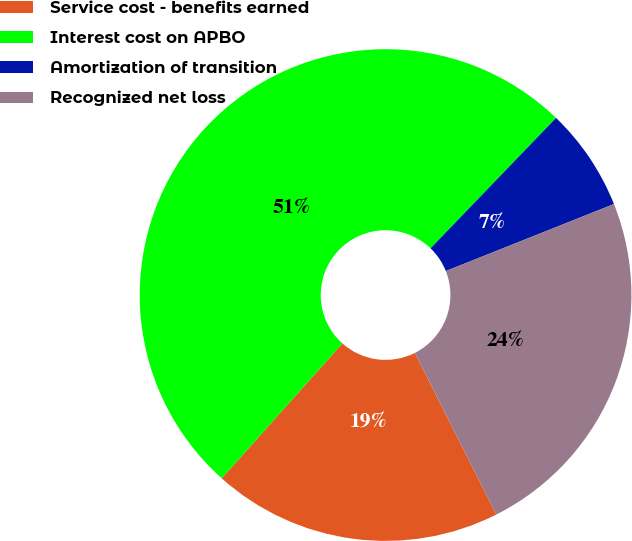<chart> <loc_0><loc_0><loc_500><loc_500><pie_chart><fcel>Service cost - benefits earned<fcel>Interest cost on APBO<fcel>Amortization of transition<fcel>Recognized net loss<nl><fcel>19.05%<fcel>50.59%<fcel>6.77%<fcel>23.6%<nl></chart> 